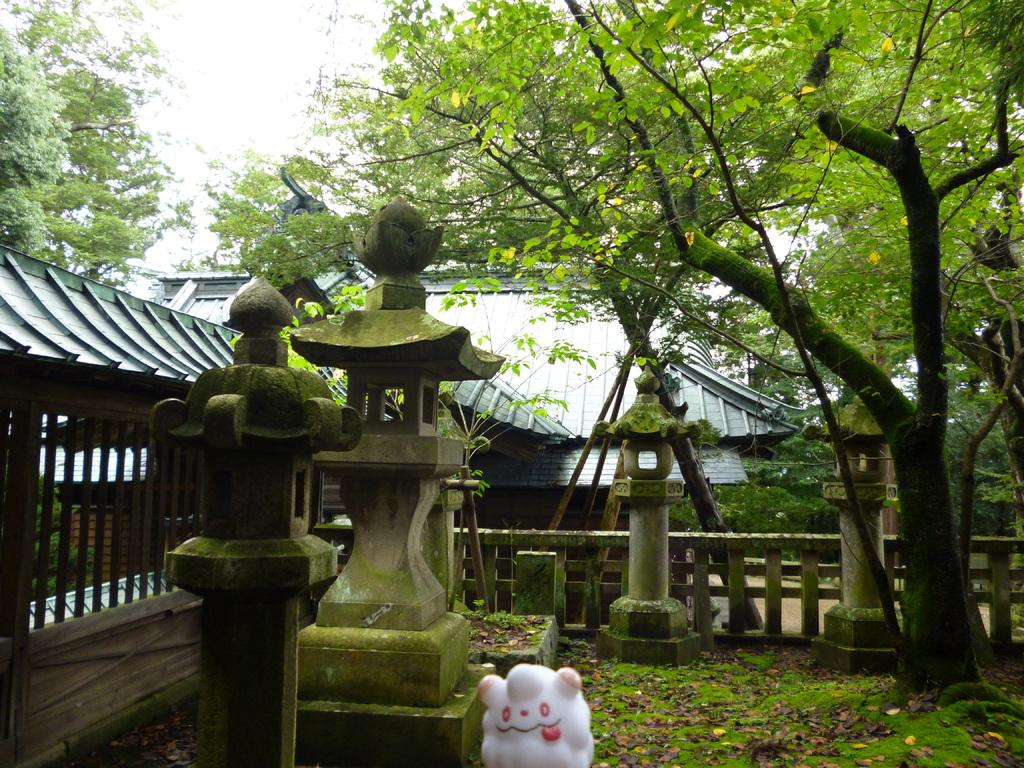What type of structure is visible in the image? There is a house in the image. What can be seen near the house? There is a railing and a grill visible in the image. What is visible in the sky in the image? The sky is visible in the image. What type of vegetation is present in the image? There are trees in the image. What object related to playtime can be seen in the image? There is a toy in the image. What type of commemorative object is present in the image? There is a memorial stone in the image. What architectural feature can be seen in the image? There are designed pillars in the image. What type of coastline can be seen in the image? There is no coastline present in the image. What part of the goose is visible in the image? There are no geese present in the image. 